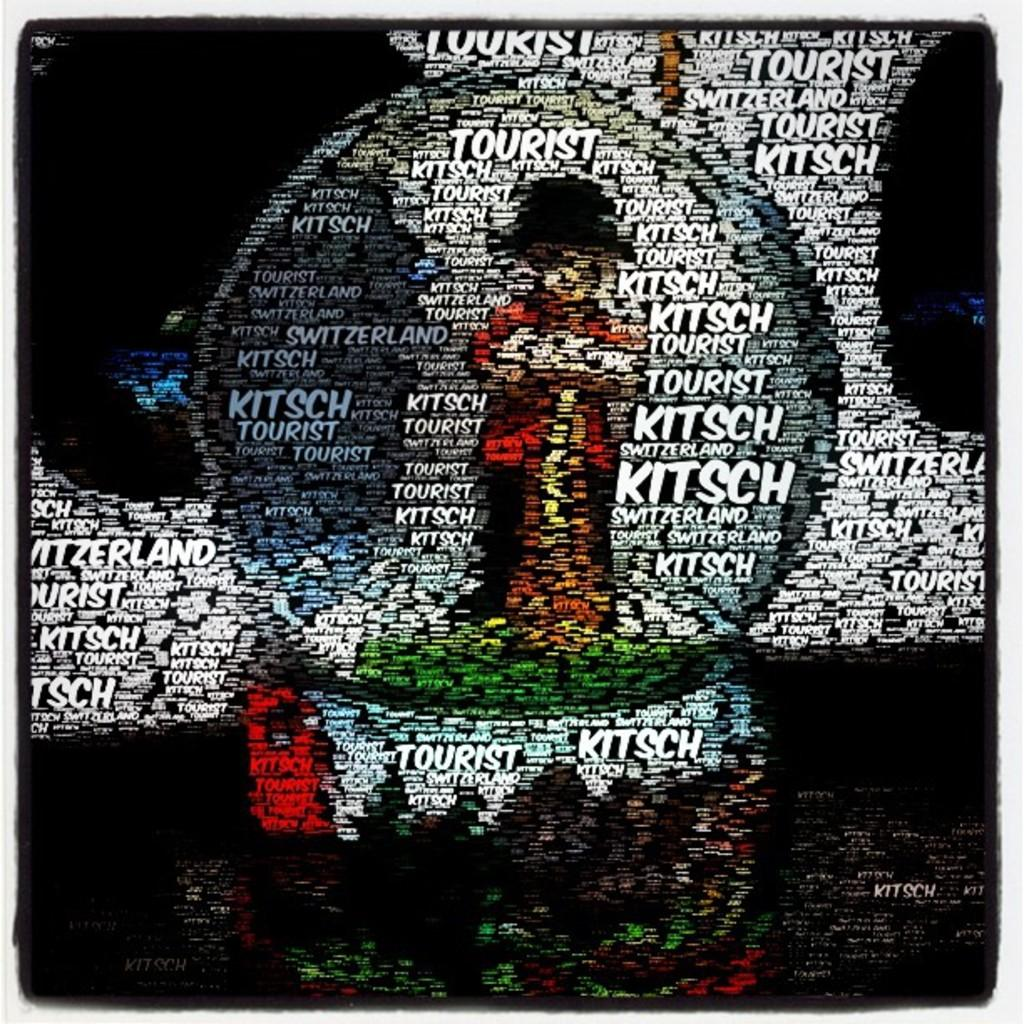<image>
Render a clear and concise summary of the photo. A piece of artwork contains the words "kitsch", "tourist" and "Switzerland" many times. 